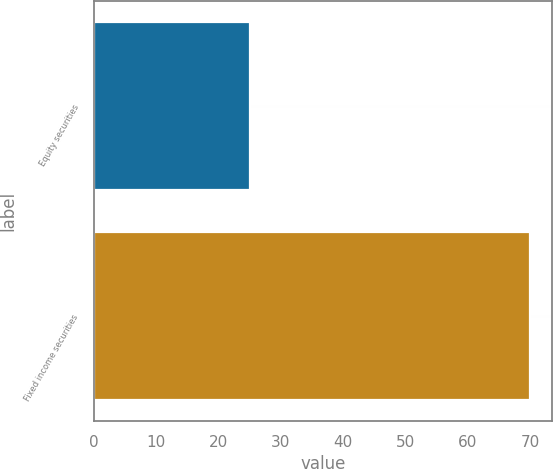Convert chart to OTSL. <chart><loc_0><loc_0><loc_500><loc_500><bar_chart><fcel>Equity securities<fcel>Fixed income securities<nl><fcel>25<fcel>70<nl></chart> 